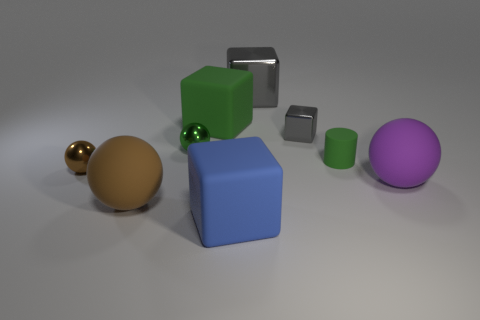Add 1 red metal cylinders. How many objects exist? 10 Subtract all cylinders. How many objects are left? 8 Subtract all green metallic objects. Subtract all gray cubes. How many objects are left? 6 Add 2 small green matte things. How many small green matte things are left? 3 Add 3 big purple things. How many big purple things exist? 4 Subtract 0 purple blocks. How many objects are left? 9 